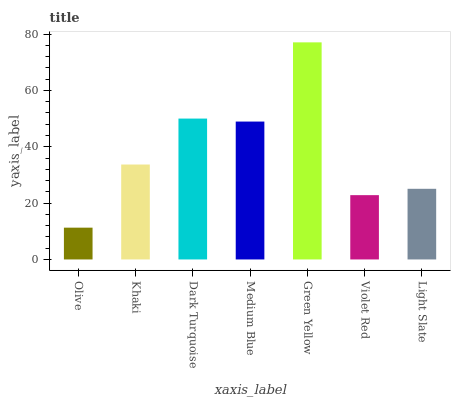Is Olive the minimum?
Answer yes or no. Yes. Is Green Yellow the maximum?
Answer yes or no. Yes. Is Khaki the minimum?
Answer yes or no. No. Is Khaki the maximum?
Answer yes or no. No. Is Khaki greater than Olive?
Answer yes or no. Yes. Is Olive less than Khaki?
Answer yes or no. Yes. Is Olive greater than Khaki?
Answer yes or no. No. Is Khaki less than Olive?
Answer yes or no. No. Is Khaki the high median?
Answer yes or no. Yes. Is Khaki the low median?
Answer yes or no. Yes. Is Olive the high median?
Answer yes or no. No. Is Dark Turquoise the low median?
Answer yes or no. No. 